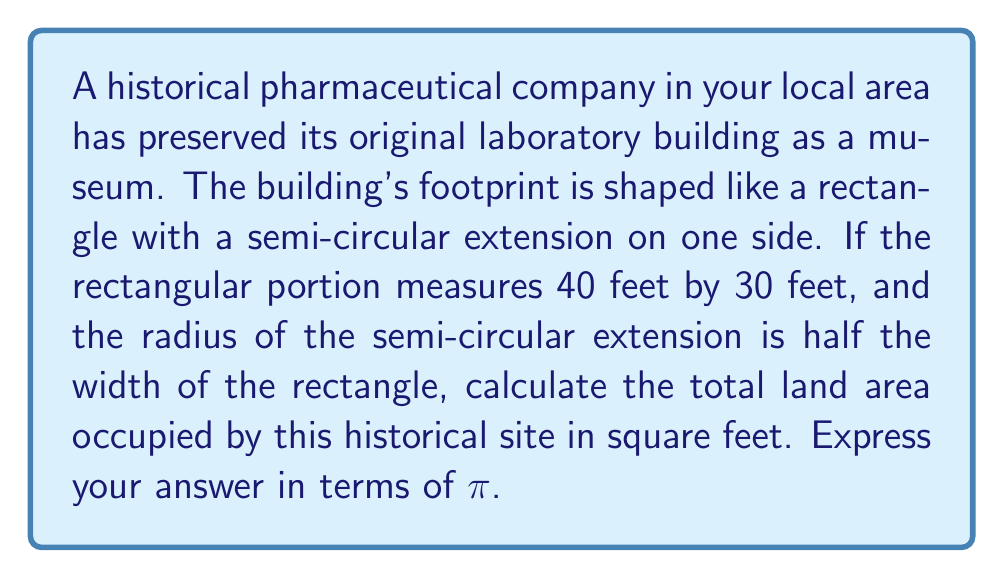Could you help me with this problem? Let's approach this step-by-step:

1) First, let's identify the shapes we're dealing with:
   - A rectangle
   - A semi-circle

2) Calculate the area of the rectangle:
   Length = 40 feet
   Width = 30 feet
   $$A_{rectangle} = l \times w = 40 \times 30 = 1200$$ sq ft

3) Calculate the radius of the semi-circle:
   The radius is half the width of the rectangle
   $$r = \frac{30}{2} = 15$$ feet

4) Calculate the area of the semi-circle:
   The formula for the area of a circle is $A = \pi r^2$
   For a semi-circle, we take half of this
   $$A_{semi-circle} = \frac{1}{2} \pi r^2 = \frac{1}{2} \pi (15)^2 = \frac{1}{2} \pi (225) = 112.5\pi$$ sq ft

5) Sum the areas:
   $$A_{total} = A_{rectangle} + A_{semi-circle}$$
   $$A_{total} = 1200 + 112.5\pi$$ sq ft

Therefore, the total area is $1200 + 112.5\pi$ square feet.
Answer: $1200 + 112.5\pi$ sq ft 